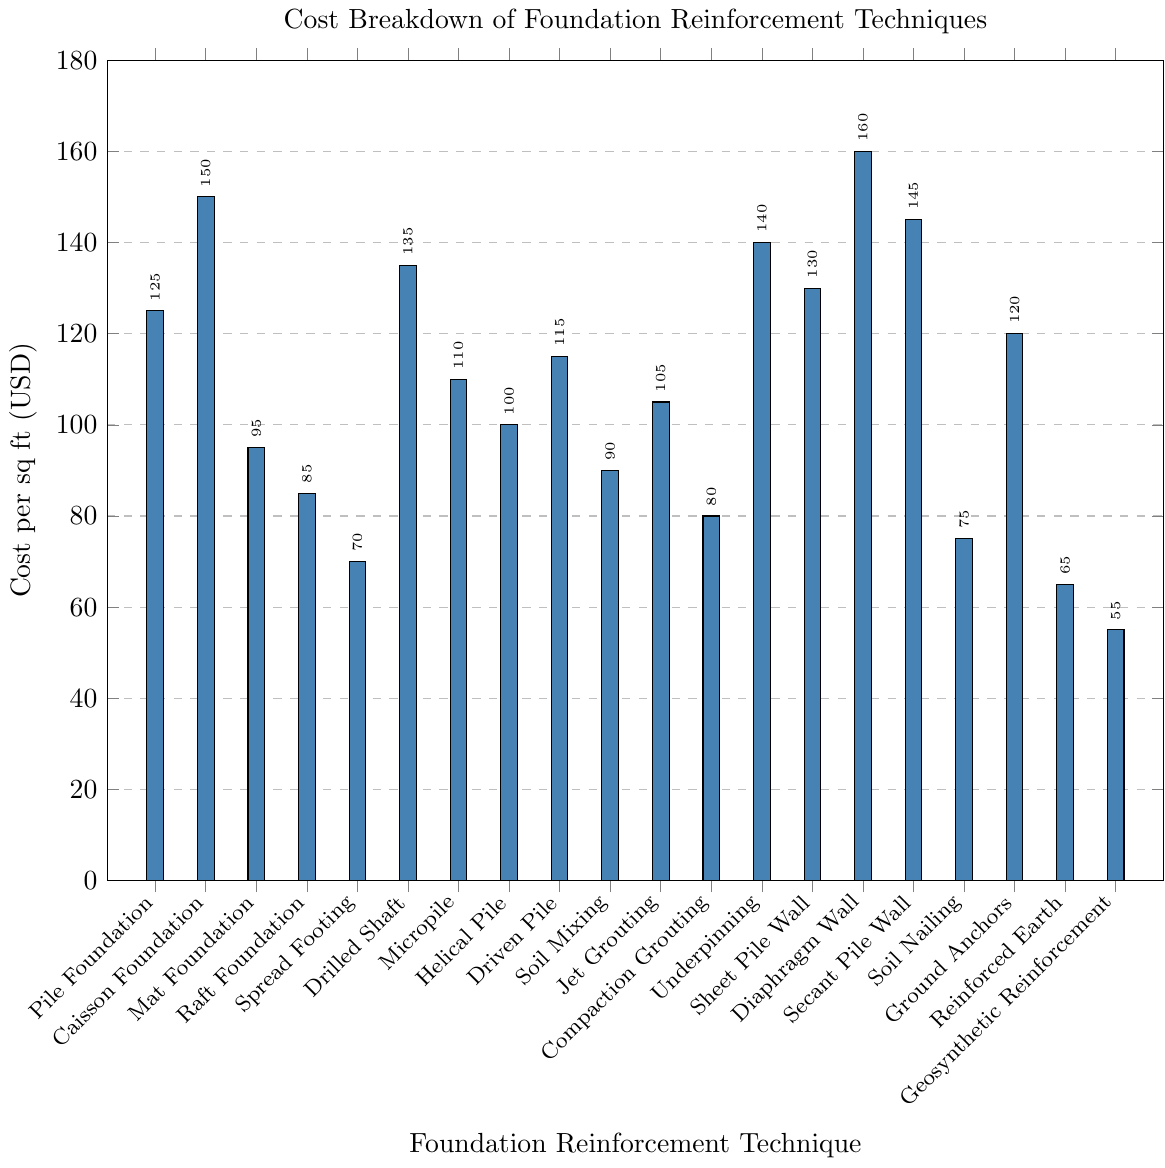What's the cost difference between the most and least expensive foundation reinforcement techniques? The most expensive technique is Diaphragm Wall with a cost of 160 USD per sq ft and the least expensive is Geosynthetic Reinforcement at 55 USD per sq ft. The difference in cost is 160 - 55 = 105 USD.
Answer: 105 USD Which foundation reinforcement technique has exactly 105 USD per sq ft cost? By looking at the bar corresponding to a height of 105 USD on the y-axis, we see that the Jet Grouting technique has this cost.
Answer: Jet Grouting How many foundation reinforcement techniques have a cost of less than 100 USD per sq ft? The techniques that cost less than 100 USD per sq ft are Mat Foundation (95), Raft Foundation (85), Spread Footing (70), Soil Mixing (90), Compaction Grouting (80), Soil Nailing (75), Reinforced Earth (65), and Geosynthetic Reinforcement (55). Counting these, there are 8 techniques.
Answer: 8 techniques What is the average cost of the Drilled Shaft and Micropile techniques? Drilled Shaft costs 135 USD per sq ft, and Micropile costs 110 USD per sq ft. The average cost is calculated as (135 + 110) / 2 = 122.5 USD per sq ft.
Answer: 122.5 USD How does the cost of a Pile Foundation compare to a Spread Footing? The cost of a Pile Foundation is 125 USD per sq ft, and Spread Footing costs 70 USD per sq ft. Therefore, the Pile Foundation is more expensive, costing 125 - 70 = 55 USD more per sq ft.
Answer: 55 USD more Which foundation reinforcement technique is the second most expensive? The most expensive technique is Diaphragm Wall (160 USD per sq ft), and the second most expensive is Caisson Foundation (150 USD per sq ft).
Answer: Caisson Foundation What is the combined cost of Soil Mixing, Compaction Grouting, and Underpinning? The cost of Soil Mixing is 90 USD per sq ft, Compaction Grouting is 80 USD per sq ft, and Underpinning is 140 USD per sq ft. The combined cost is 90 + 80 + 140 = 310 USD per sq ft.
Answer: 310 USD What is the median cost of all listed foundation reinforcement techniques? First, arrange the costs in ascending order: 55, 65, 70, 75, 80, 85, 90, 95, 100, 105, 110, 115, 120, 125, 130, 135, 140, 145, 150, 160. The median is the average of the 10th and 11th values: (105+110)/2 = 107.5 USD per sq ft.
Answer: 107.5 USD How many techniques have a cost between 90 and 130 USD per sq ft inclusive? Techniques within this range are Mat Foundation (95), Raft Foundation (85), Helical Pile (100), Jet Grouting (105), Compaction Grouting (80), Underpinning (140), Sheet Pile Wall (130), Soil Mixing (90), Micropile (110), and Spread Footing (70). There are 10 such techniques.
Answer: 10 techniques If you were to use Ground Anchors and Underpinning for a total of 200 sq ft area, what would be the total cost? Ground Anchors cost 120 USD per sq ft and Underpinning costs 140 USD per sq ft. For 100 sq ft each, the cost is (120 * 100) + (140 * 100) = 12000 + 14000 = 26000 USD.
Answer: 26000 USD 